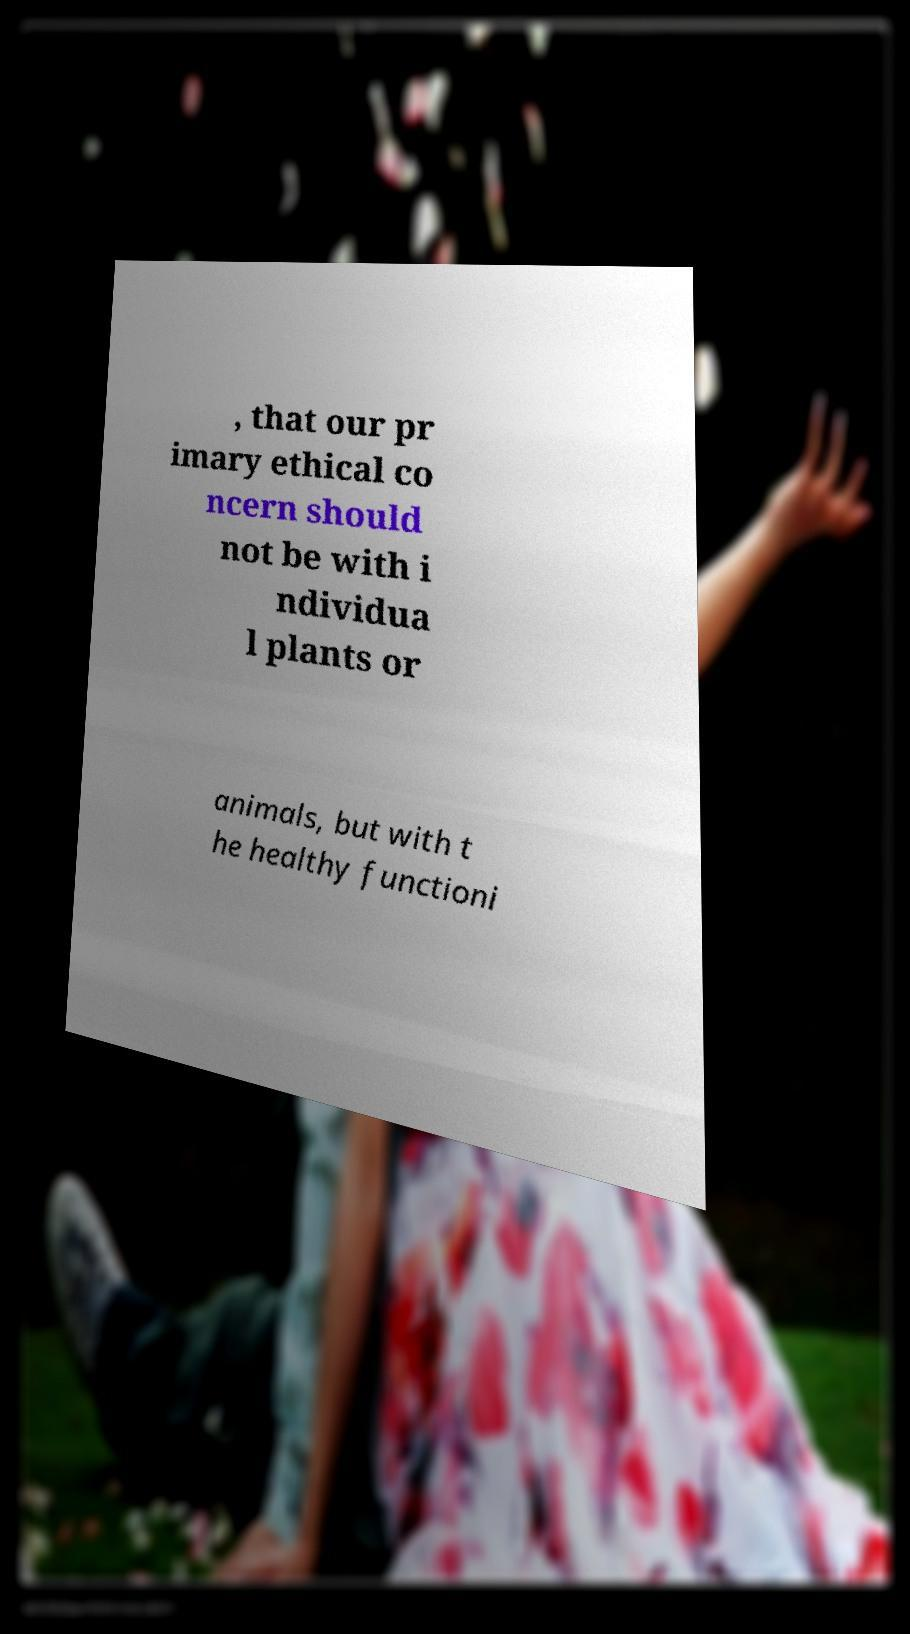Please read and relay the text visible in this image. What does it say? , that our pr imary ethical co ncern should not be with i ndividua l plants or animals, but with t he healthy functioni 